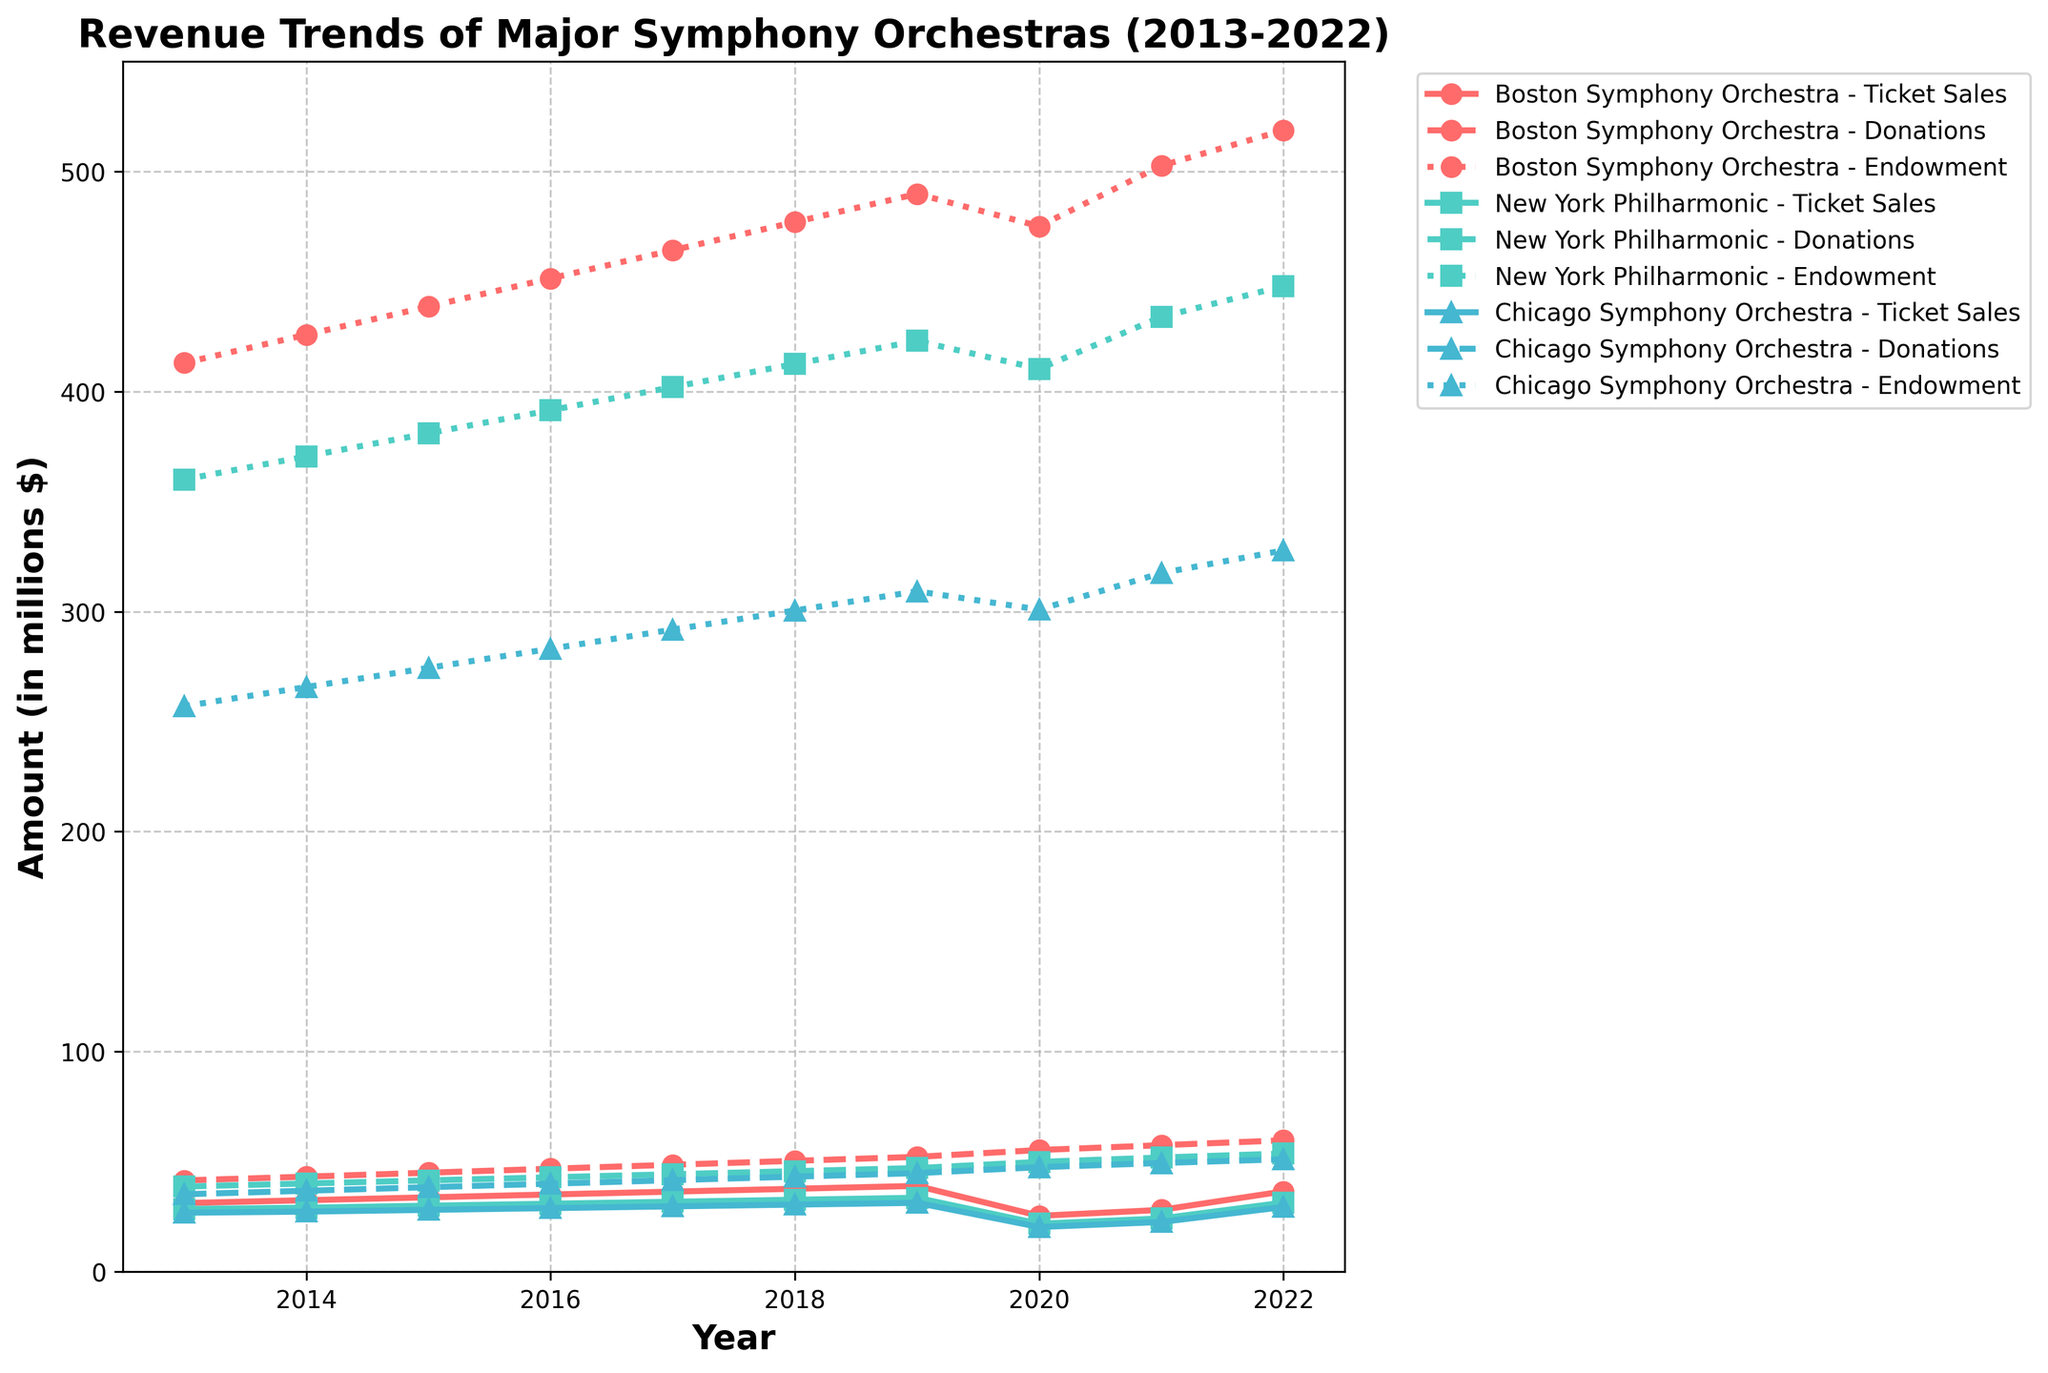What is the trend of ticket sales for the Boston Symphony Orchestra from 2013 to 2022? The ticket sales for the Boston Symphony Orchestra show a general upward trend from 2013 (31.2 million) to 2022 (36.5 million). There's a notable dip in 2020 (25.4 million) likely due to the pandemic, followed by a sharp increase to 2022.
Answer: Upward trend, with a dip in 2020 How do the endowment values compare among all three orchestras in 2022? The Boston Symphony Orchestra has the highest endowment in 2022 (518.7 million), followed by the New York Philharmonic (447.9 million) and the Chicago Symphony Orchestra (327.8 million).
Answer: Boston Symphony Orchestra > New York Philharmonic > Chicago Symphony Orchestra Which orchestra received the highest amount in donations in 2022 and by how much? The Boston Symphony Orchestra received the highest donations in 2022 (59.7 million) compared to the New York Philharmonic (53.7 million) and the Chicago Symphony Orchestra (51.1 million). The difference with the second highest, New York Philharmonic, is 6 million (59.7 - 53.7).
Answer: Boston Symphony Orchestra by 6 million What was the impact of the year 2020 on the ticket sales of all three orchestras? In 2020, ticket sales dropped significantly for all three orchestras. Boston Symphony went from 39.0 to 25.4 million, New York Philharmonic from 33.6 to 21.8 million, and Chicago Symphony from 31.3 to 20.3 million.
Answer: Significant drop for all Which revenue stream had the least variability for the New York Philharmonic over the decade? The endowment values for the New York Philharmonic show a slight, consistent increase from 360.0 million in 2013 to 447.9 million in 2022, indicating the least variability compared to ticket sales and donations.
Answer: Endowment values How did the Chicago Symphony Orchestra's donations change from 2015 to 2021? The donations for the Chicago Symphony Orchestra increased from 38.4 million in 2015 to 49.4 million in 2021. This shows an increase by 11 million.
Answer: Increased by 11 million Between 2019 and 2022, which orchestra showed the fastest recovery in ticket sales? The Boston Symphony Orchestra recovered fastest in ticket sales, increasing from 25.4 million in 2020 to 36.5 million in 2022, a recovery of 11.1 million. New York Philharmonic and Chicago Symphony had recoveries of 9.6 million and 9.1 million respectively.
Answer: Boston Symphony Orchestra Compare the donations trends of the Boston Symphony Orchestra and the Chicago Symphony Orchestra from 2016 to 2022. Between 2016 and 2022, donations for the Boston Symphony Orchestra increased from 46.8 million to 59.7 million, while for the Chicago Symphony Orchestra it increased from 40.0 million to 51.1 million. Both show upward trends, but Boston Symphony has a higher absolute increase.
Answer: Both upwards, Boston Symphony Orchestra higher increase 